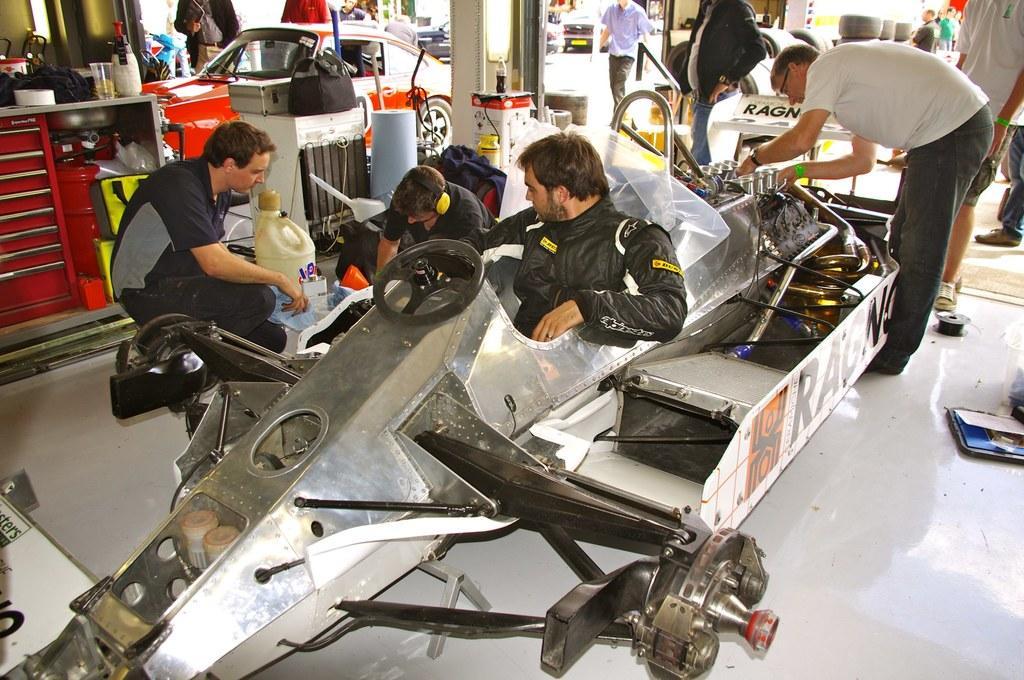How would you summarize this image in a sentence or two? In this image we can see there are a few people standing and few people sitting and there is the other person sitting in the vehicle. And we can see there are vehicles on the ground and there is a table, on the table there are boxes, bottle, glass, bags, tires and few objects. 